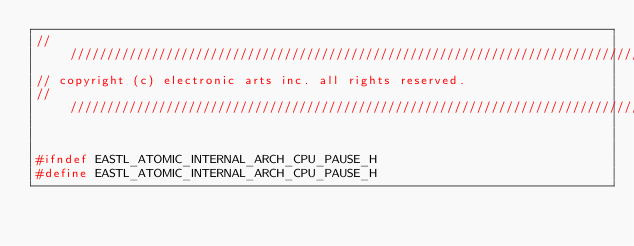<code> <loc_0><loc_0><loc_500><loc_500><_C_>/////////////////////////////////////////////////////////////////////////////////
// copyright (c) electronic arts inc. all rights reserved.
/////////////////////////////////////////////////////////////////////////////////


#ifndef EASTL_ATOMIC_INTERNAL_ARCH_CPU_PAUSE_H
#define EASTL_ATOMIC_INTERNAL_ARCH_CPU_PAUSE_H
</code> 